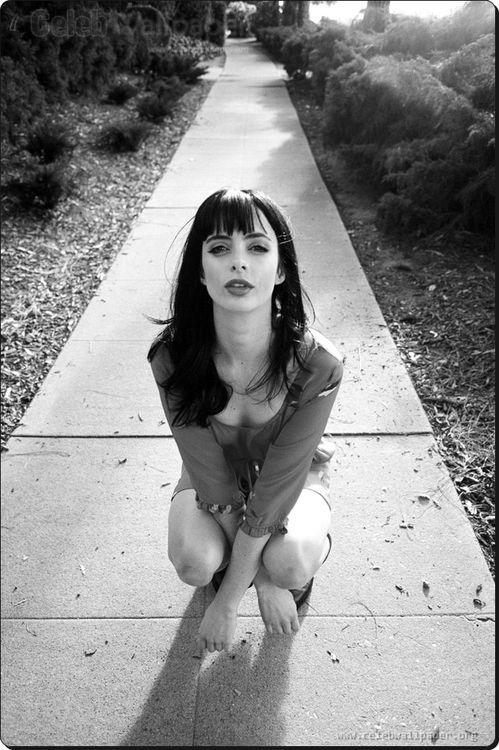What's the story behind this image? This image seems to capture a reflective and contemplative moment of the actress Krysten Ritter. It might be part of a photoshoot aiming to highlight her emotional depth and versatility. The stark black and white contrast, with her intense expression, suggests a theme of introspection or perhaps a narrative that draws the viewer into a deeper, unseen story. 